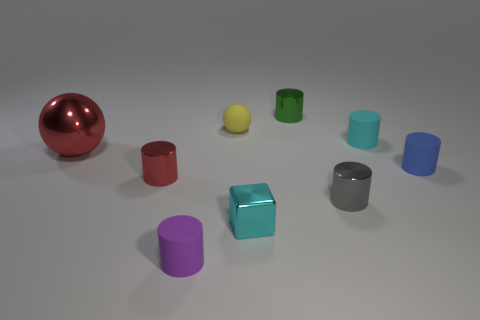Is there anything else that is made of the same material as the small blue thing?
Your response must be concise. Yes. There is a cyan thing that is the same shape as the small green metal thing; what material is it?
Your response must be concise. Rubber. Is the number of small green objects that are in front of the cyan rubber cylinder less than the number of tiny purple rubber balls?
Make the answer very short. No. There is a metal ball; what number of cylinders are behind it?
Your answer should be very brief. 2. Is the shape of the cyan object that is to the right of the gray metal cylinder the same as the small metallic thing to the right of the small green metallic thing?
Provide a succinct answer. Yes. What is the shape of the metal object that is both right of the red cylinder and behind the small red shiny thing?
Your response must be concise. Cylinder. What size is the red cylinder that is the same material as the tiny green thing?
Provide a short and direct response. Small. Is the number of big purple rubber things less than the number of small green objects?
Give a very brief answer. Yes. The yellow sphere behind the tiny metallic object right of the tiny shiny cylinder that is behind the tiny yellow matte thing is made of what material?
Offer a terse response. Rubber. Are the sphere right of the small red shiny object and the cyan object that is behind the small cyan shiny object made of the same material?
Make the answer very short. Yes. 